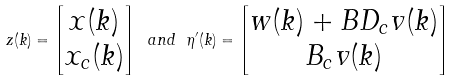<formula> <loc_0><loc_0><loc_500><loc_500>z ( k ) = \begin{bmatrix} x ( k ) \\ x _ { c } ( k ) \end{bmatrix} \ a n d \ \eta ^ { \prime } ( k ) = \begin{bmatrix} w ( k ) + B D _ { c } v ( k ) \\ B _ { c } v ( k ) \end{bmatrix}</formula> 